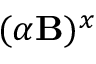Convert formula to latex. <formula><loc_0><loc_0><loc_500><loc_500>( \alpha { B } ) ^ { x }</formula> 